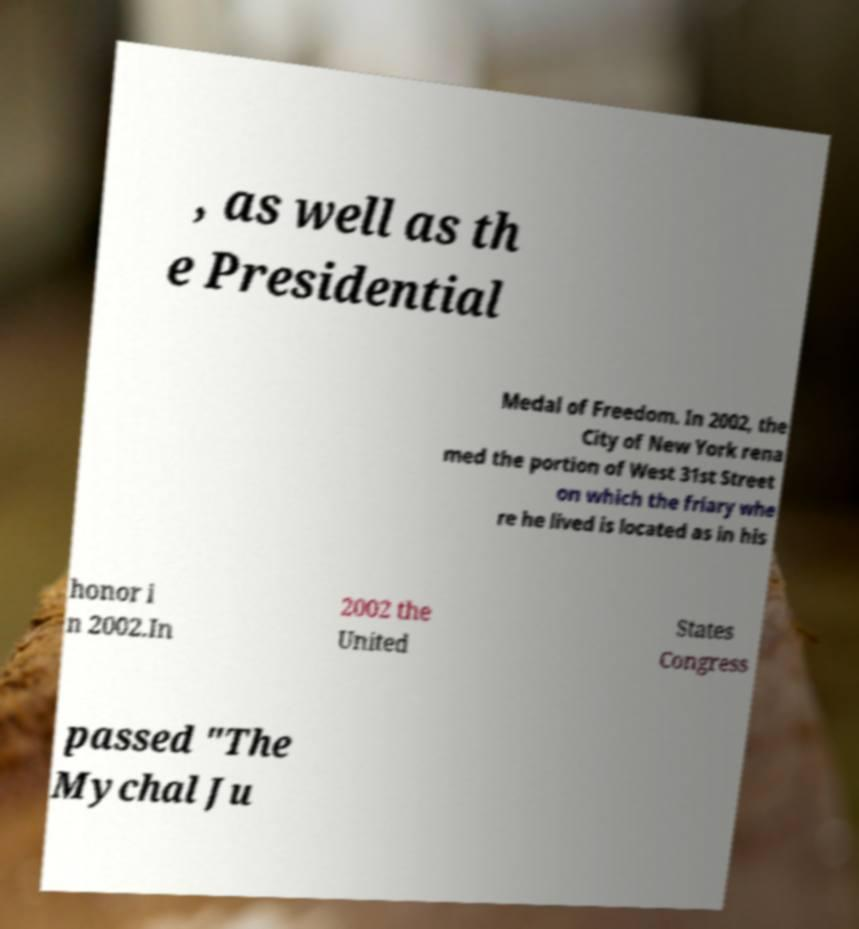Please identify and transcribe the text found in this image. , as well as th e Presidential Medal of Freedom. In 2002, the City of New York rena med the portion of West 31st Street on which the friary whe re he lived is located as in his honor i n 2002.In 2002 the United States Congress passed "The Mychal Ju 